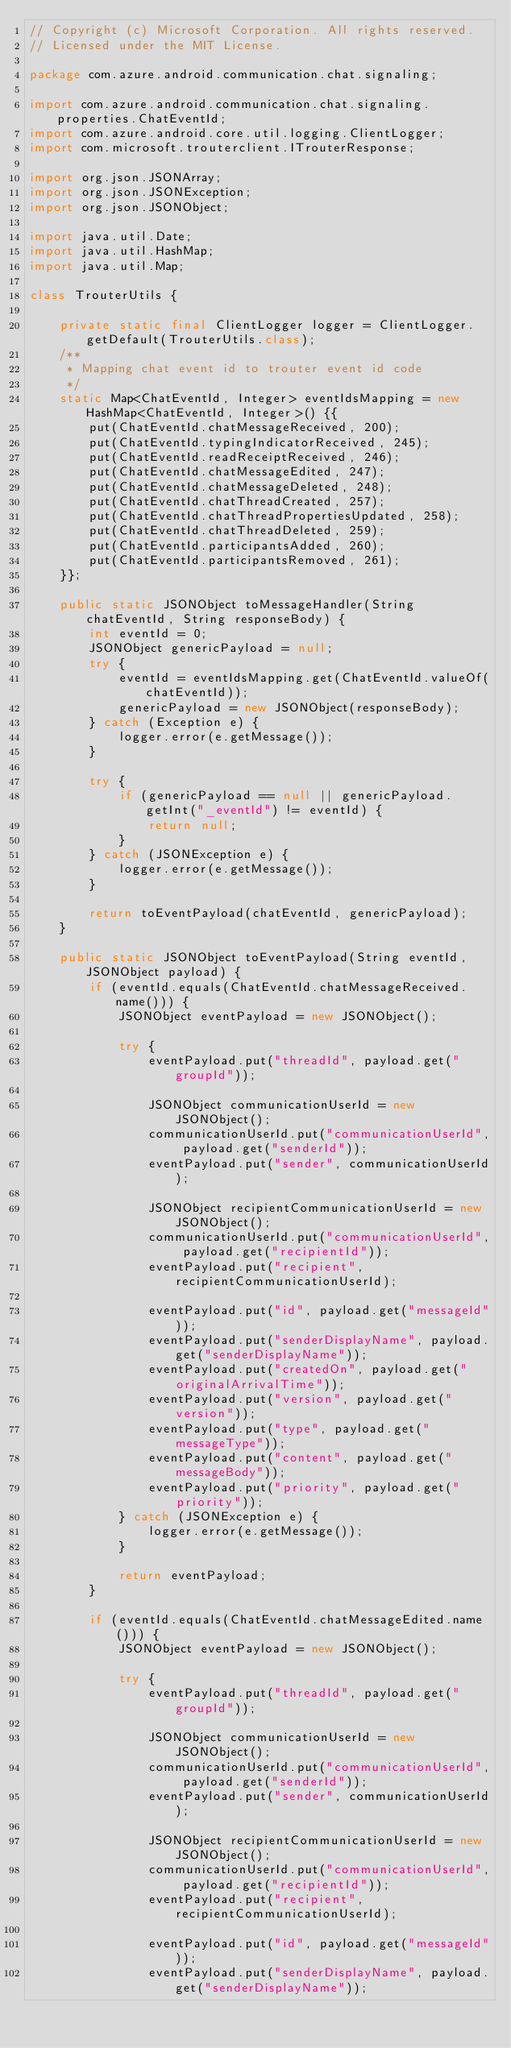<code> <loc_0><loc_0><loc_500><loc_500><_Java_>// Copyright (c) Microsoft Corporation. All rights reserved.
// Licensed under the MIT License.

package com.azure.android.communication.chat.signaling;

import com.azure.android.communication.chat.signaling.properties.ChatEventId;
import com.azure.android.core.util.logging.ClientLogger;
import com.microsoft.trouterclient.ITrouterResponse;

import org.json.JSONArray;
import org.json.JSONException;
import org.json.JSONObject;

import java.util.Date;
import java.util.HashMap;
import java.util.Map;

class TrouterUtils {

    private static final ClientLogger logger = ClientLogger.getDefault(TrouterUtils.class);
    /**
     * Mapping chat event id to trouter event id code
     */
    static Map<ChatEventId, Integer> eventIdsMapping = new HashMap<ChatEventId, Integer>() {{
        put(ChatEventId.chatMessageReceived, 200);
        put(ChatEventId.typingIndicatorReceived, 245);
        put(ChatEventId.readReceiptReceived, 246);
        put(ChatEventId.chatMessageEdited, 247);
        put(ChatEventId.chatMessageDeleted, 248);
        put(ChatEventId.chatThreadCreated, 257);
        put(ChatEventId.chatThreadPropertiesUpdated, 258);
        put(ChatEventId.chatThreadDeleted, 259);
        put(ChatEventId.participantsAdded, 260);
        put(ChatEventId.participantsRemoved, 261);
    }};

    public static JSONObject toMessageHandler(String chatEventId, String responseBody) {
        int eventId = 0;
        JSONObject genericPayload = null;
        try {
            eventId = eventIdsMapping.get(ChatEventId.valueOf(chatEventId));
            genericPayload = new JSONObject(responseBody);
        } catch (Exception e) {
            logger.error(e.getMessage());
        }

        try {
            if (genericPayload == null || genericPayload.getInt("_eventId") != eventId) {
                return null;
            }
        } catch (JSONException e) {
            logger.error(e.getMessage());
        }

        return toEventPayload(chatEventId, genericPayload);
    }

    public static JSONObject toEventPayload(String eventId, JSONObject payload) {
        if (eventId.equals(ChatEventId.chatMessageReceived.name())) {
            JSONObject eventPayload = new JSONObject();

            try {
                eventPayload.put("threadId", payload.get("groupId"));

                JSONObject communicationUserId = new JSONObject();
                communicationUserId.put("communicationUserId", payload.get("senderId"));
                eventPayload.put("sender", communicationUserId);

                JSONObject recipientCommunicationUserId = new JSONObject();
                communicationUserId.put("communicationUserId", payload.get("recipientId"));
                eventPayload.put("recipient", recipientCommunicationUserId);

                eventPayload.put("id", payload.get("messageId"));
                eventPayload.put("senderDisplayName", payload.get("senderDisplayName"));
                eventPayload.put("createdOn", payload.get("originalArrivalTime"));
                eventPayload.put("version", payload.get("version"));
                eventPayload.put("type", payload.get("messageType"));
                eventPayload.put("content", payload.get("messageBody"));
                eventPayload.put("priority", payload.get("priority"));
            } catch (JSONException e) {
                logger.error(e.getMessage());
            }

            return eventPayload;
        }

        if (eventId.equals(ChatEventId.chatMessageEdited.name())) {
            JSONObject eventPayload = new JSONObject();

            try {
                eventPayload.put("threadId", payload.get("groupId"));

                JSONObject communicationUserId = new JSONObject();
                communicationUserId.put("communicationUserId", payload.get("senderId"));
                eventPayload.put("sender", communicationUserId);

                JSONObject recipientCommunicationUserId = new JSONObject();
                communicationUserId.put("communicationUserId", payload.get("recipientId"));
                eventPayload.put("recipient", recipientCommunicationUserId);

                eventPayload.put("id", payload.get("messageId"));
                eventPayload.put("senderDisplayName", payload.get("senderDisplayName"));</code> 